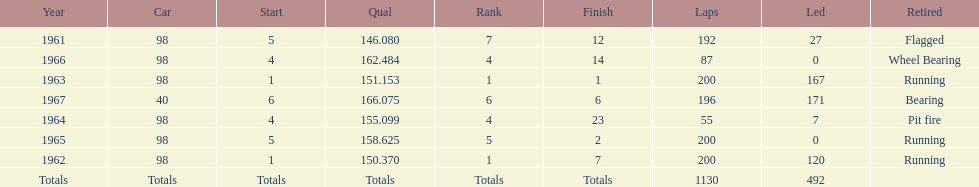How many total laps have been driven in the indy 500? 1130. 